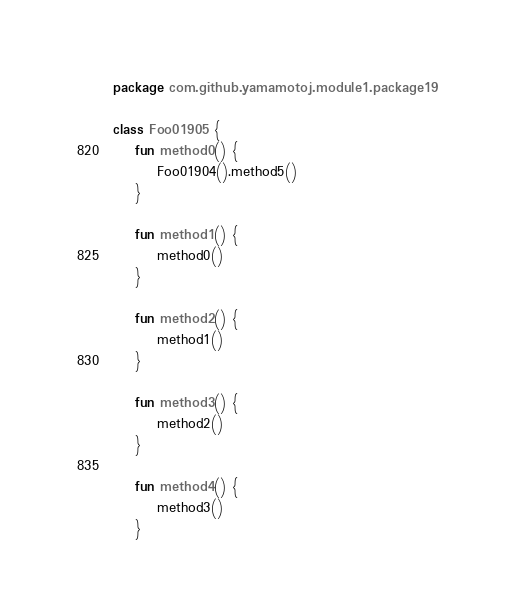Convert code to text. <code><loc_0><loc_0><loc_500><loc_500><_Kotlin_>package com.github.yamamotoj.module1.package19

class Foo01905 {
    fun method0() {
        Foo01904().method5()
    }

    fun method1() {
        method0()
    }

    fun method2() {
        method1()
    }

    fun method3() {
        method2()
    }

    fun method4() {
        method3()
    }
</code> 